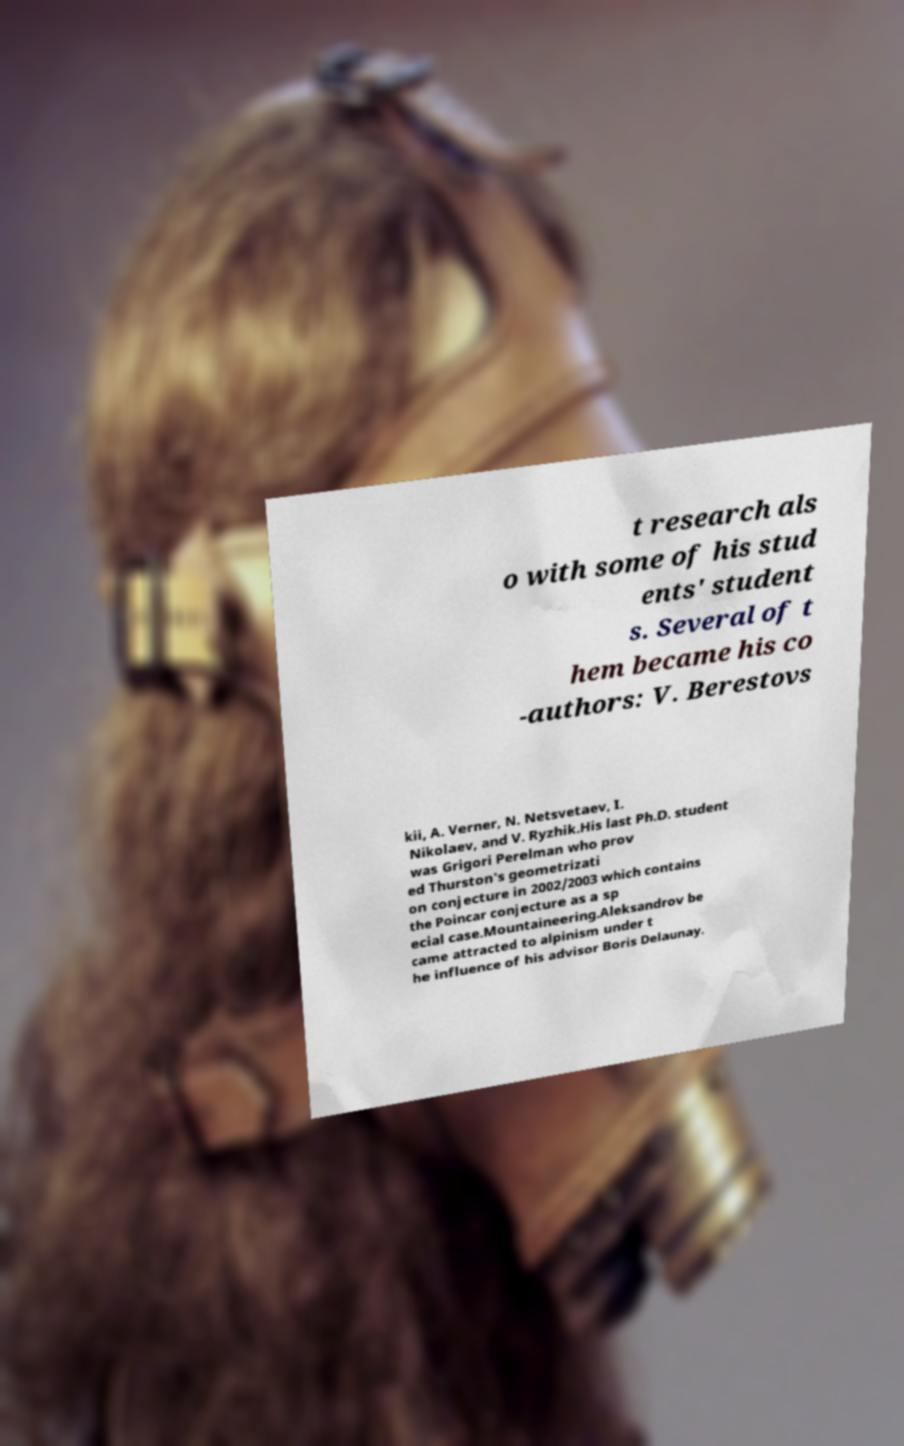Could you extract and type out the text from this image? t research als o with some of his stud ents' student s. Several of t hem became his co -authors: V. Berestovs kii, A. Verner, N. Netsvetaev, I. Nikolaev, and V. Ryzhik.His last Ph.D. student was Grigori Perelman who prov ed Thurston's geometrizati on conjecture in 2002/2003 which contains the Poincar conjecture as a sp ecial case.Mountaineering.Aleksandrov be came attracted to alpinism under t he influence of his advisor Boris Delaunay. 